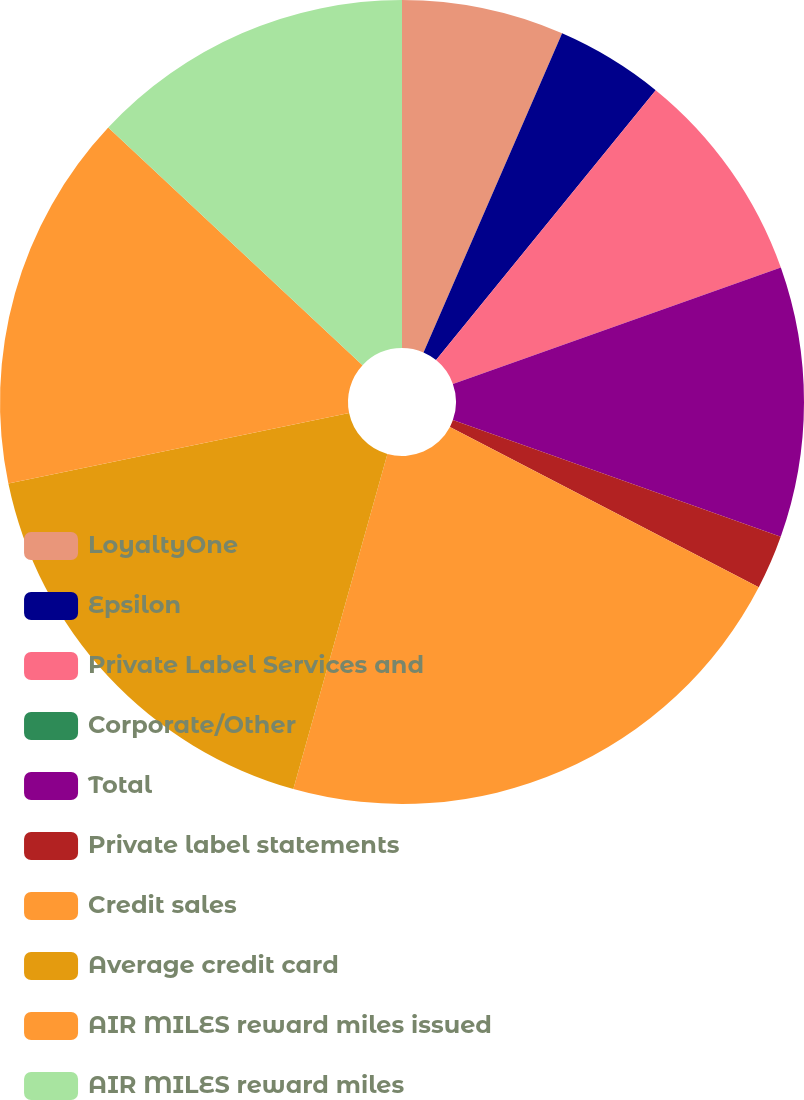Convert chart to OTSL. <chart><loc_0><loc_0><loc_500><loc_500><pie_chart><fcel>LoyaltyOne<fcel>Epsilon<fcel>Private Label Services and<fcel>Corporate/Other<fcel>Total<fcel>Private label statements<fcel>Credit sales<fcel>Average credit card<fcel>AIR MILES reward miles issued<fcel>AIR MILES reward miles<nl><fcel>6.52%<fcel>4.35%<fcel>8.7%<fcel>0.0%<fcel>10.87%<fcel>2.18%<fcel>21.73%<fcel>17.39%<fcel>15.21%<fcel>13.04%<nl></chart> 